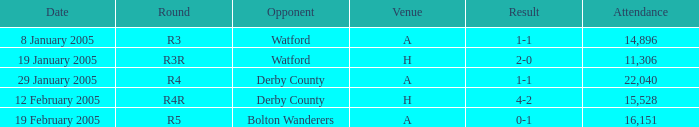Could you parse the entire table? {'header': ['Date', 'Round', 'Opponent', 'Venue', 'Result', 'Attendance'], 'rows': [['8 January 2005', 'R3', 'Watford', 'A', '1-1', '14,896'], ['19 January 2005', 'R3R', 'Watford', 'H', '2-0', '11,306'], ['29 January 2005', 'R4', 'Derby County', 'A', '1-1', '22,040'], ['12 February 2005', 'R4R', 'Derby County', 'H', '4-2', '15,528'], ['19 February 2005', 'R5', 'Bolton Wanderers', 'A', '0-1', '16,151']]} What is the round of the game at venue H and opponent of Derby County? R4R. 